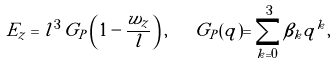<formula> <loc_0><loc_0><loc_500><loc_500>E _ { z } = l ^ { 3 } \, G _ { P } \left ( 1 - \frac { w _ { z } } { l } \right ) , \quad G _ { P } ( q ) = \sum _ { k = 0 } ^ { 3 } \beta _ { k } q ^ { k } ,</formula> 